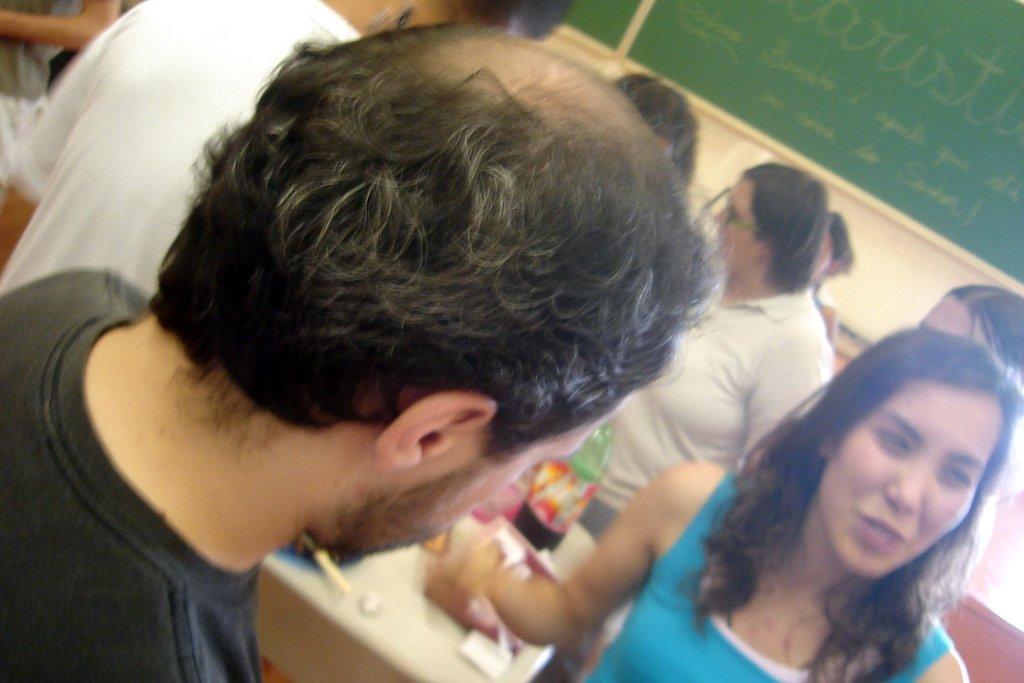Describe this image in one or two sentences. In this image there are group of people standing, there are some objects and a bottle on the table, and in the background there are boards to the wall. 